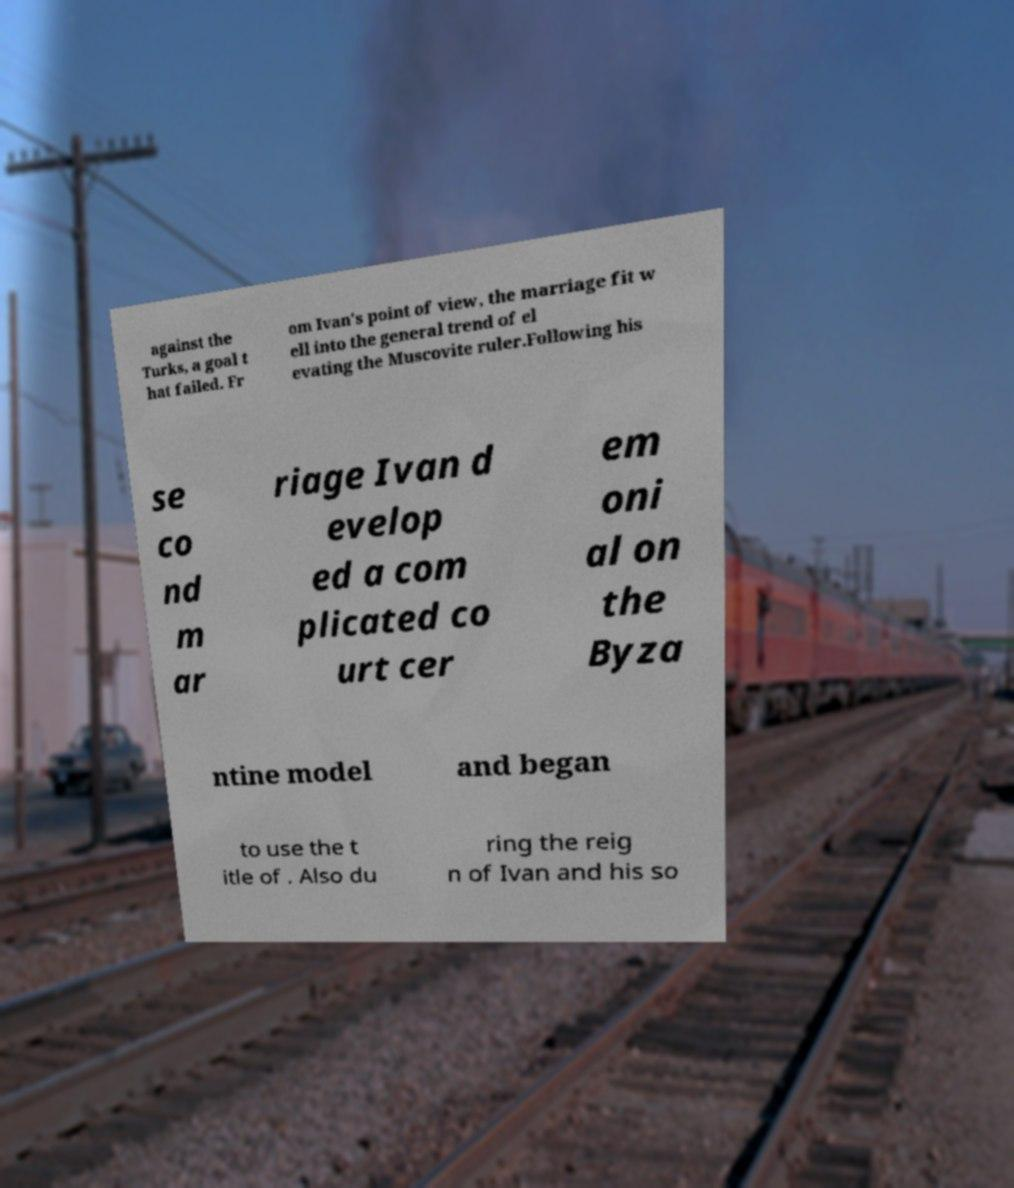There's text embedded in this image that I need extracted. Can you transcribe it verbatim? against the Turks, a goal t hat failed. Fr om Ivan's point of view, the marriage fit w ell into the general trend of el evating the Muscovite ruler.Following his se co nd m ar riage Ivan d evelop ed a com plicated co urt cer em oni al on the Byza ntine model and began to use the t itle of . Also du ring the reig n of Ivan and his so 